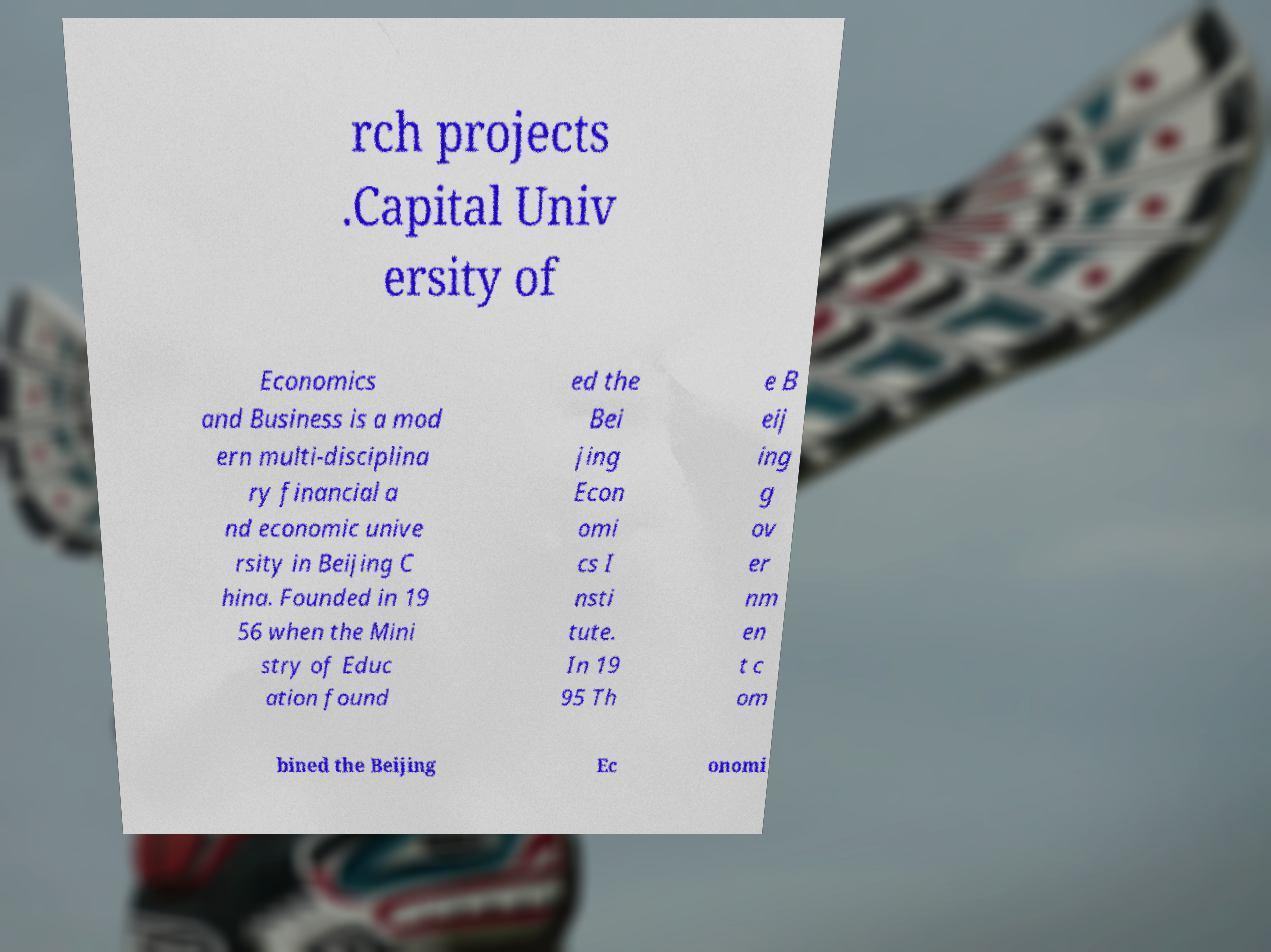What messages or text are displayed in this image? I need them in a readable, typed format. rch projects .Capital Univ ersity of Economics and Business is a mod ern multi-disciplina ry financial a nd economic unive rsity in Beijing C hina. Founded in 19 56 when the Mini stry of Educ ation found ed the Bei jing Econ omi cs I nsti tute. In 19 95 Th e B eij ing g ov er nm en t c om bined the Beijing Ec onomi 